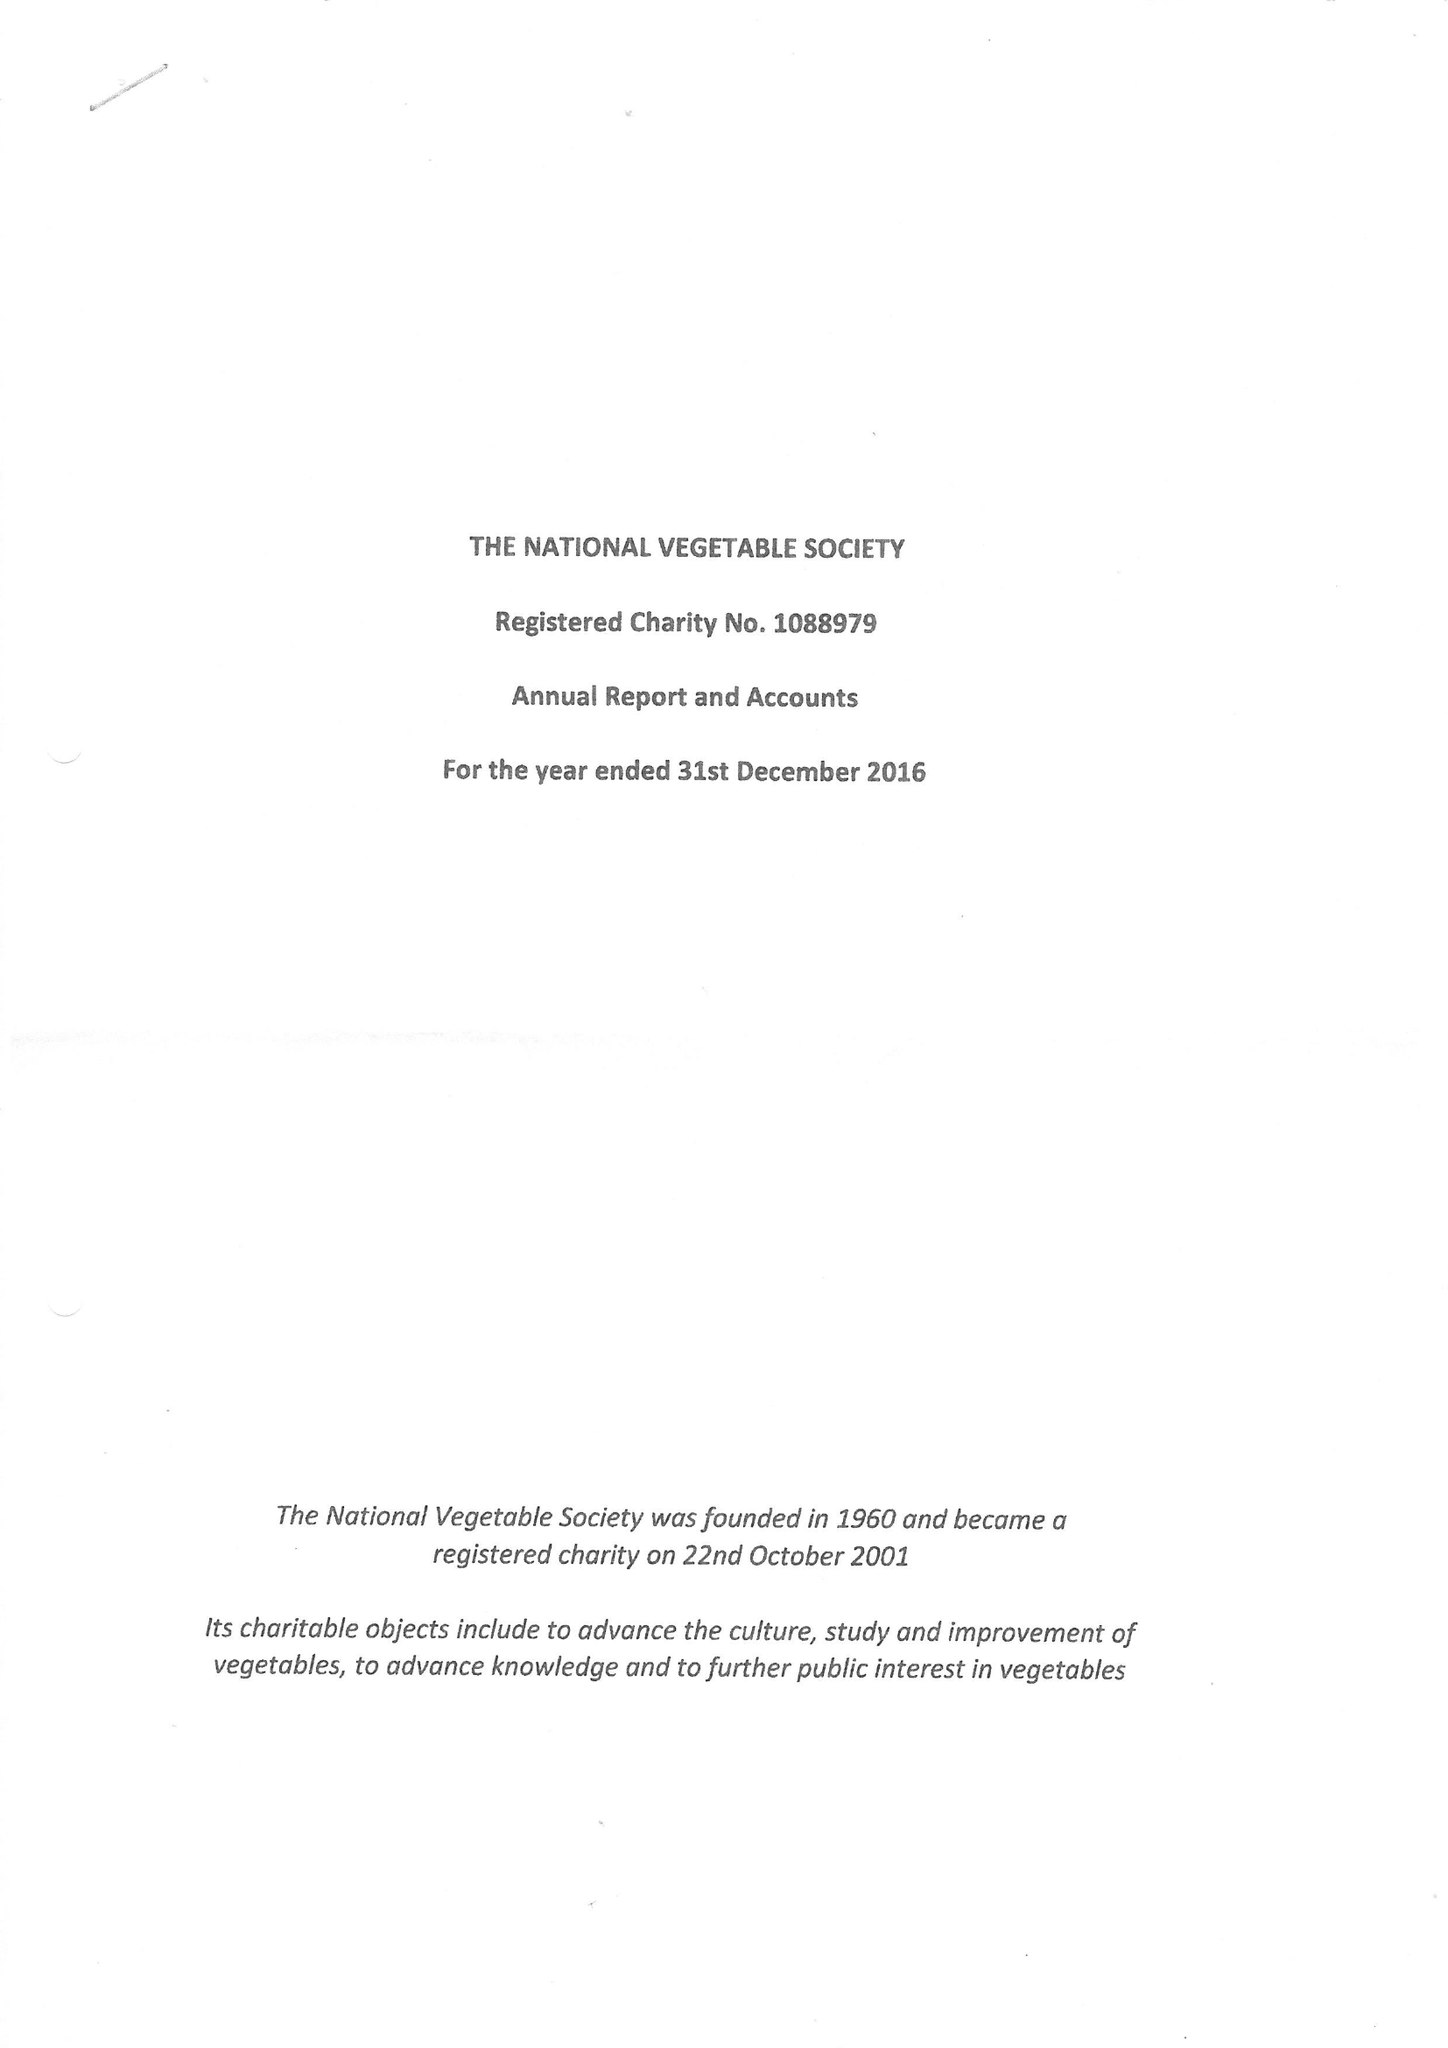What is the value for the report_date?
Answer the question using a single word or phrase. 2016-12-31 